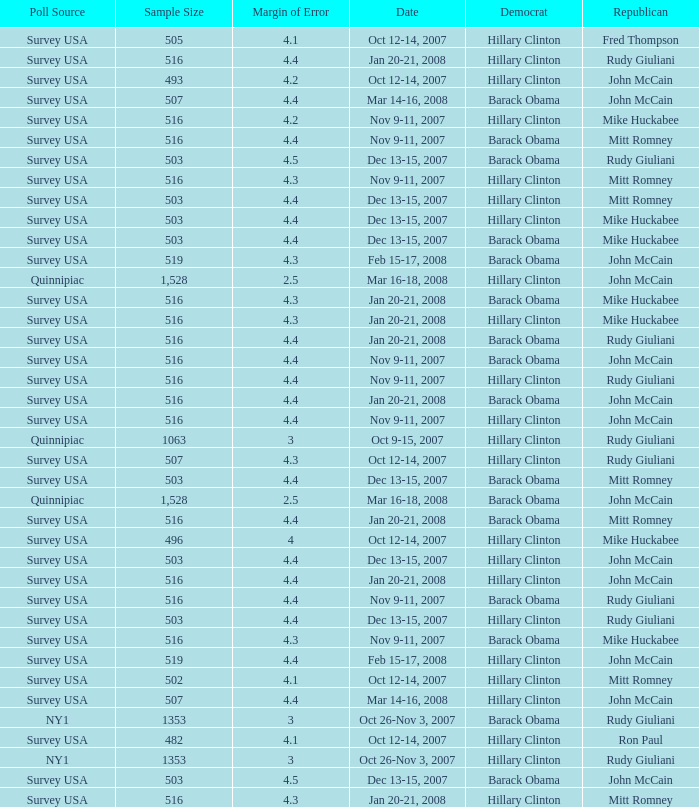What was the date of the poll with a sample size of 496 where Republican Mike Huckabee was chosen? Oct 12-14, 2007. 